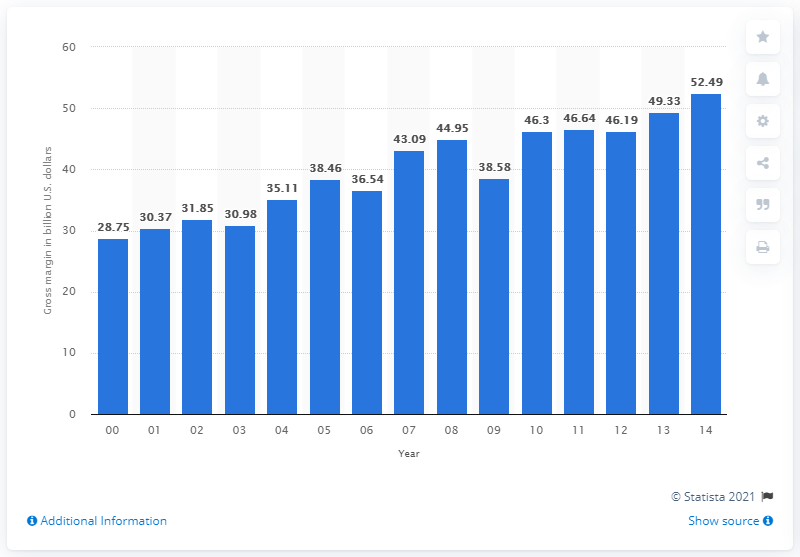List a handful of essential elements in this visual. In 2014, the gross margin on apparel, piece goods, and notions in the U.S. wholesale industry was 52.49%. 